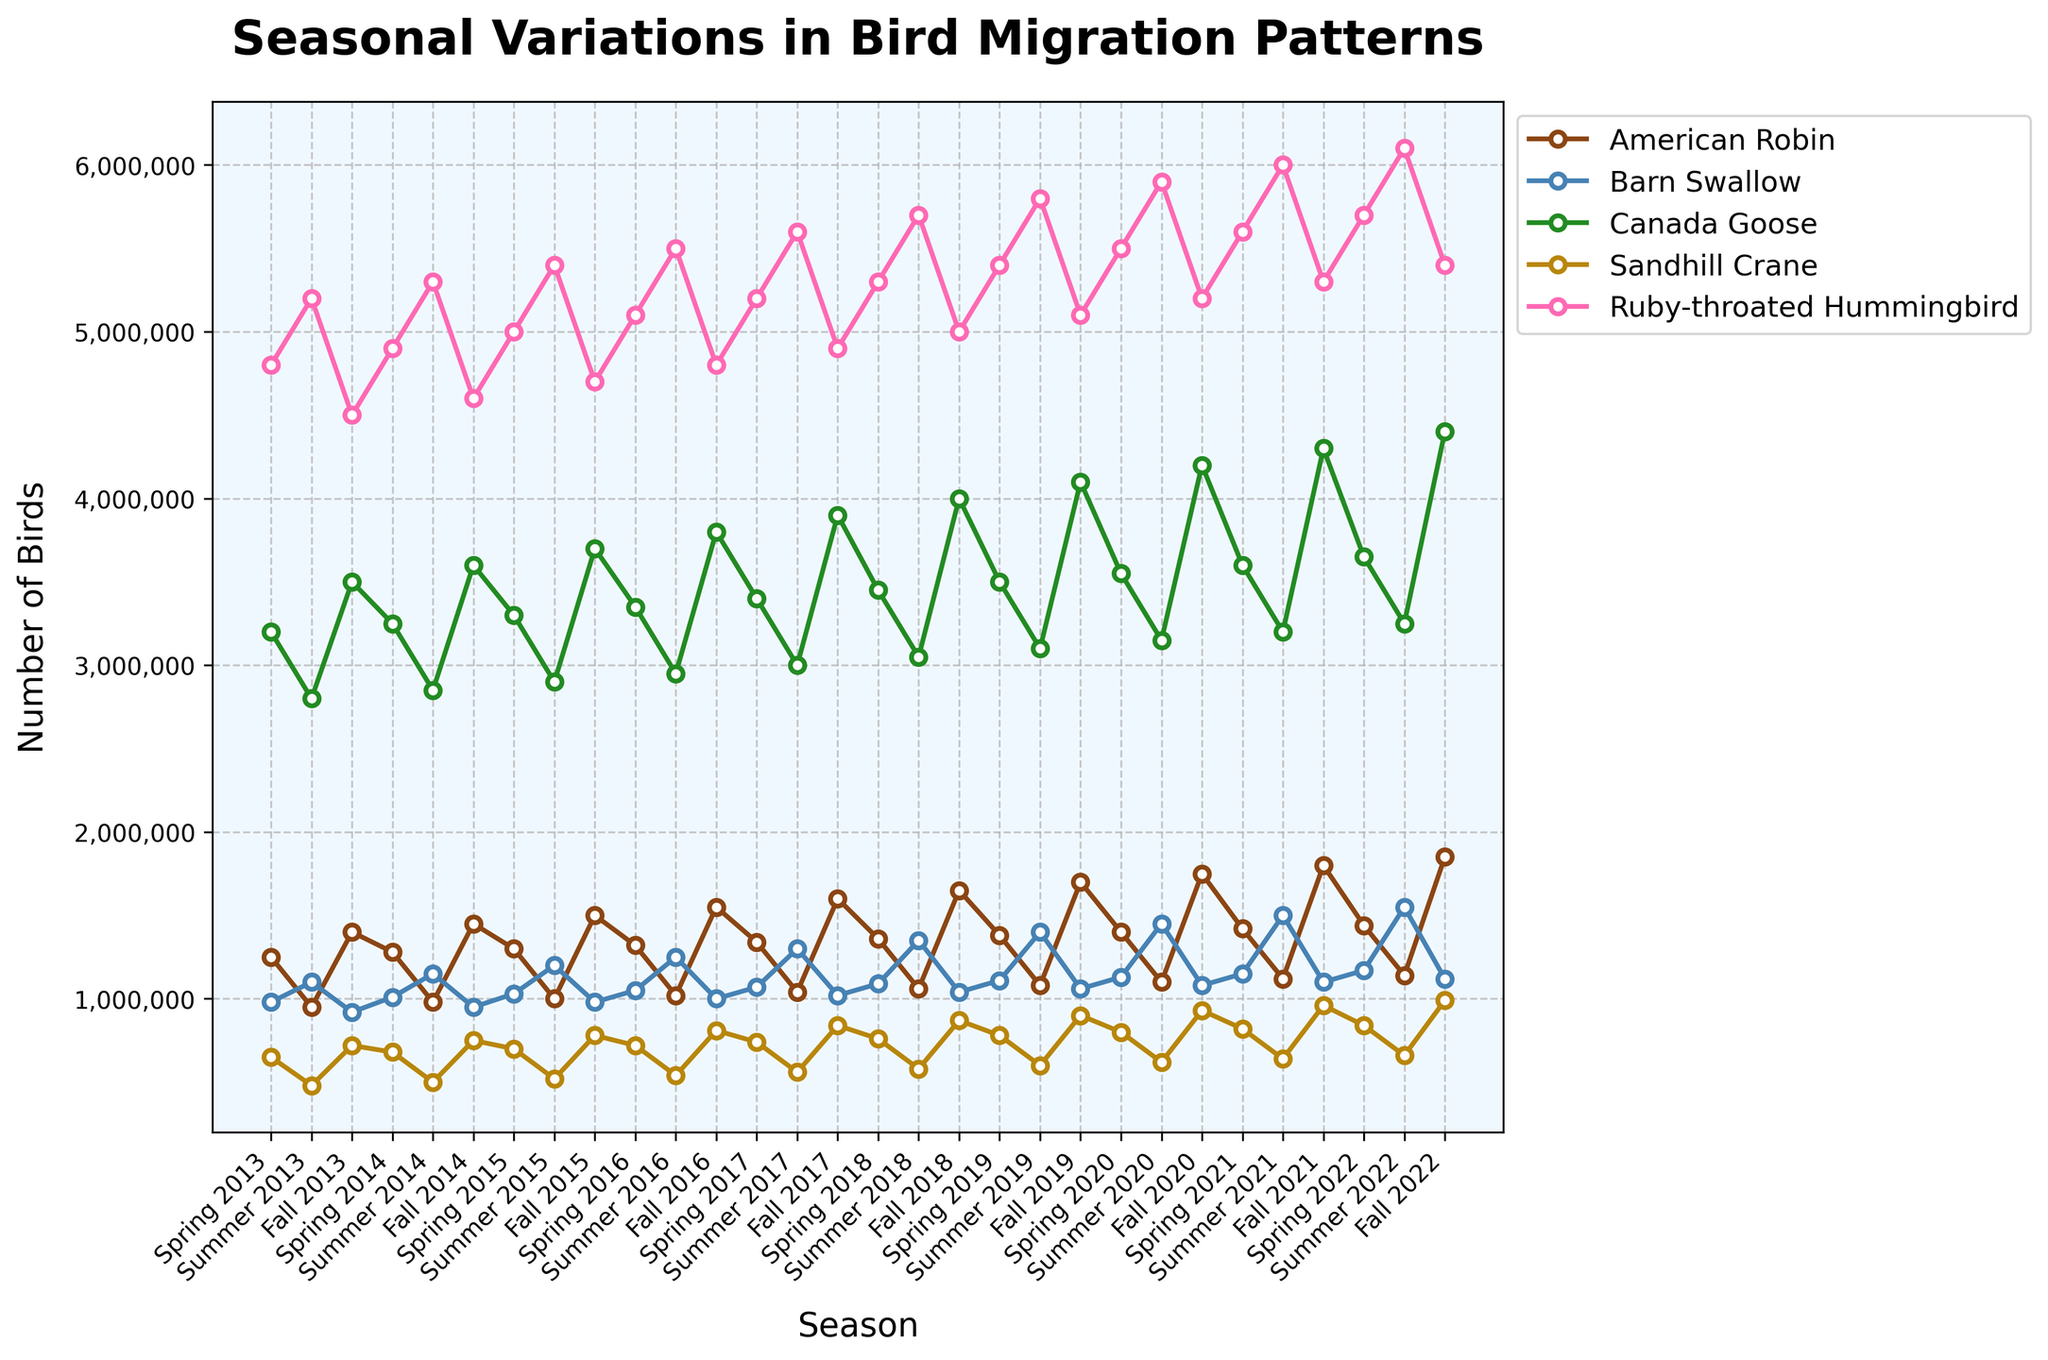Which bird has the highest population during Fall 2022? By examining the plot, we notice that the Ruby-throated Hummingbird line is the highest during the Fall 2022 season.
Answer: Ruby-throated Hummingbird How did the number of Barn Swallows change from Spring 2013 to Fall 2022? The Barn Swallow population in Spring 2013 is around 980,000, and in Fall 2022, it is approximately 1,120,000. The change is 1,120,000 - 980,000 = 140,000.
Answer: Increased by 140,000 Which season shows the highest number of Canada Geese? By inspecting the chart, we find that Canada Geese have the highest population during the Fall 2022 season.
Answer: Fall 2022 What is the average number of American Robins in Spring from 2013 to 2022? Calculate the average by summing the populations in Spring seasons and dividing by the number of years: (1,250,000 + 1,280,000 + 1,300,000 + 1,320,000 + 1,340,000 + 1,360,000 + 1,380,000 + 1,400,000 + 1,420,000 + 1,440,000) / 10 = 1,349,000.
Answer: 1,349,000 In which year did the Ruby-throated Hummingbird have the lowest population during Spring? Looking through the Spring seasons for the Ruby-throated Hummingbird, the lowest population is around 4,800,000 in Spring 2013.
Answer: Spring 2013 Compare the population trends of Sandhill Cranes and Barn Swallows over time. The plot shows that Sandhill Cranes have a relatively lower population in Spring and higher in Fall. Barn Swallows show a less clear seasonal pattern but gradually increase over time. Both species have increasing trends.
Answer: Both increasing trends, but Sandhill Cranes more seasonal Which bird shows the most consistent population trend across all seasons? Observing the plot, the Ruby-throated Hummingbird maintains relatively consistent seasonal populations compared to other birds with more fluctuation.
Answer: Ruby-throated Hummingbird What is the difference between the highest and lowest recorded populations for American Robin from 2013 to 2022? The highest recorded population for American Robin is 1,850,000, and the lowest is 950,000. The difference is 1,850,000 - 950,000 = 900,000.
Answer: 900,000 